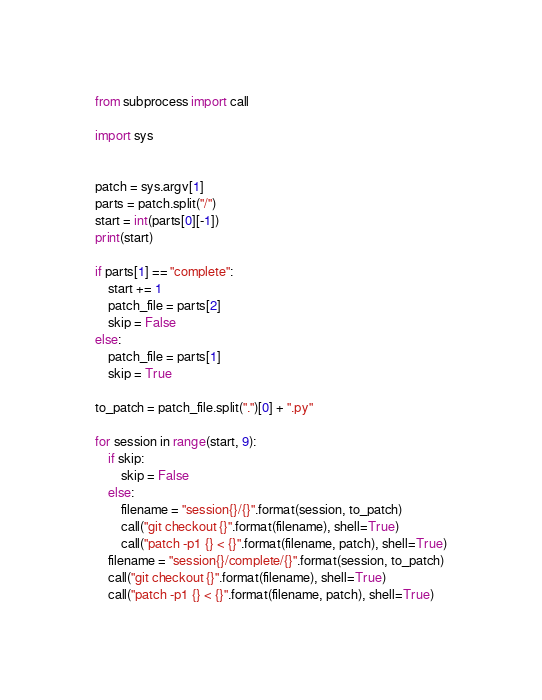Convert code to text. <code><loc_0><loc_0><loc_500><loc_500><_Python_>from subprocess import call

import sys


patch = sys.argv[1]
parts = patch.split("/")
start = int(parts[0][-1])
print(start)

if parts[1] == "complete":
    start += 1
    patch_file = parts[2]
    skip = False
else:
    patch_file = parts[1]
    skip = True

to_patch = patch_file.split(".")[0] + ".py"

for session in range(start, 9):
    if skip:
        skip = False
    else:
        filename = "session{}/{}".format(session, to_patch)
        call("git checkout {}".format(filename), shell=True)
        call("patch -p1 {} < {}".format(filename, patch), shell=True)
    filename = "session{}/complete/{}".format(session, to_patch)
    call("git checkout {}".format(filename), shell=True)
    call("patch -p1 {} < {}".format(filename, patch), shell=True)
</code> 